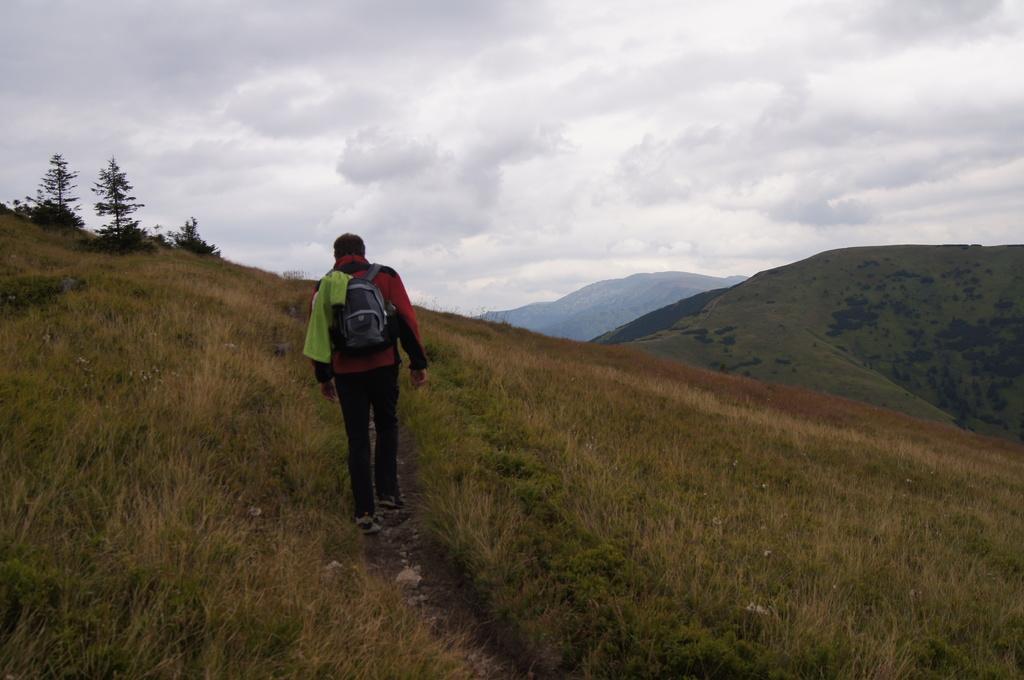How would you summarize this image in a sentence or two? In the background we can see the sky. In this picture we can see the hills, grass and trees. We can see a person wearing a backpack, jacket and he is walking. 